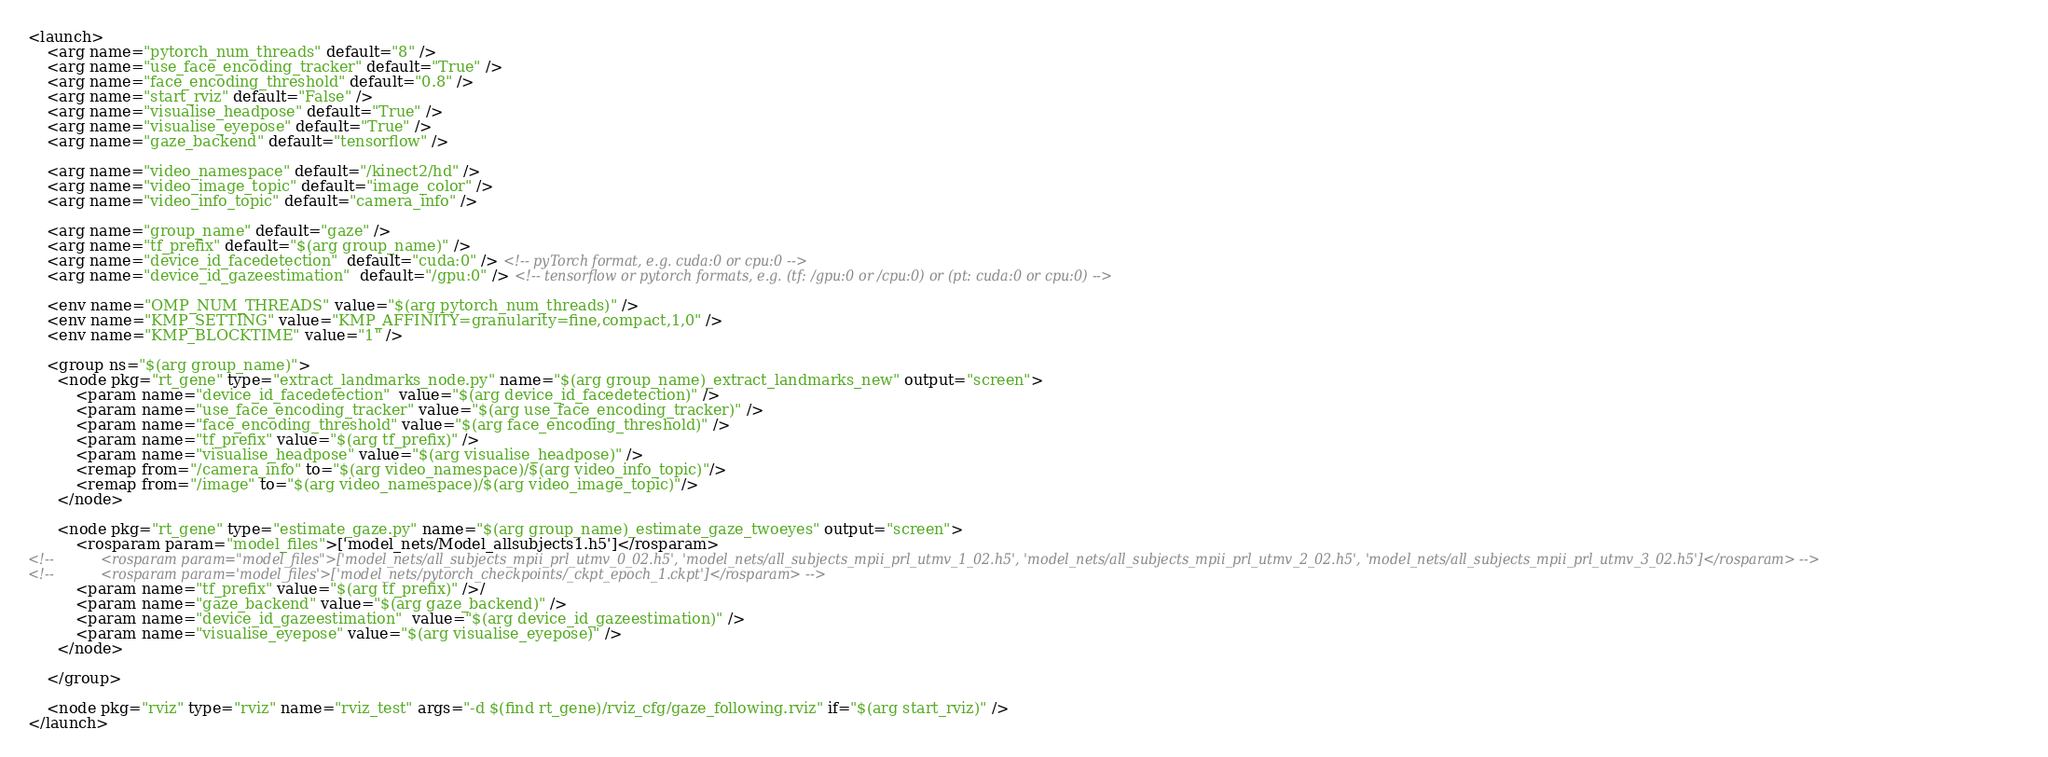Convert code to text. <code><loc_0><loc_0><loc_500><loc_500><_XML_><launch>
    <arg name="pytorch_num_threads" default="8" />
    <arg name="use_face_encoding_tracker" default="True" />
    <arg name="face_encoding_threshold" default="0.8" />
    <arg name="start_rviz" default="False" />
    <arg name="visualise_headpose" default="True" />
    <arg name="visualise_eyepose" default="True" />
    <arg name="gaze_backend" default="tensorflow" />

    <arg name="video_namespace" default="/kinect2/hd" />
    <arg name="video_image_topic" default="image_color" />
    <arg name="video_info_topic" default="camera_info" />

    <arg name="group_name" default="gaze" />
    <arg name="tf_prefix" default="$(arg group_name)" />
    <arg name="device_id_facedetection"  default="cuda:0" /> <!-- pyTorch format, e.g. cuda:0 or cpu:0 -->
    <arg name="device_id_gazeestimation"  default="/gpu:0" /> <!-- tensorflow or pytorch formats, e.g. (tf: /gpu:0 or /cpu:0) or (pt: cuda:0 or cpu:0) -->

    <env name="OMP_NUM_THREADS" value="$(arg pytorch_num_threads)" />
    <env name="KMP_SETTING" value="KMP_AFFINITY=granularity=fine,compact,1,0" />
    <env name="KMP_BLOCKTIME" value="1" />

    <group ns="$(arg group_name)">
      <node pkg="rt_gene" type="extract_landmarks_node.py" name="$(arg group_name)_extract_landmarks_new" output="screen">
          <param name="device_id_facedetection"  value="$(arg device_id_facedetection)" />
          <param name="use_face_encoding_tracker" value="$(arg use_face_encoding_tracker)" />
          <param name="face_encoding_threshold" value="$(arg face_encoding_threshold)" />
          <param name="tf_prefix" value="$(arg tf_prefix)" />
          <param name="visualise_headpose" value="$(arg visualise_headpose)" />
          <remap from="/camera_info" to="$(arg video_namespace)/$(arg video_info_topic)"/>
          <remap from="/image" to="$(arg video_namespace)/$(arg video_image_topic)"/>
      </node>

      <node pkg="rt_gene" type="estimate_gaze.py" name="$(arg group_name)_estimate_gaze_twoeyes" output="screen">
          <rosparam param="model_files">['model_nets/Model_allsubjects1.h5']</rosparam>
<!--           <rosparam param="model_files">['model_nets/all_subjects_mpii_prl_utmv_0_02.h5', 'model_nets/all_subjects_mpii_prl_utmv_1_02.h5', 'model_nets/all_subjects_mpii_prl_utmv_2_02.h5', 'model_nets/all_subjects_mpii_prl_utmv_3_02.h5']</rosparam> -->
<!--           <rosparam param='model_files'>['model_nets/pytorch_checkpoints/_ckpt_epoch_1.ckpt']</rosparam> -->
          <param name="tf_prefix" value="$(arg tf_prefix)" />/
          <param name="gaze_backend" value="$(arg gaze_backend)" />
          <param name="device_id_gazeestimation"  value="$(arg device_id_gazeestimation)" />
          <param name="visualise_eyepose" value="$(arg visualise_eyepose)" />
      </node>

    </group>

    <node pkg="rviz" type="rviz" name="rviz_test" args="-d $(find rt_gene)/rviz_cfg/gaze_following.rviz" if="$(arg start_rviz)" />
</launch>

</code> 